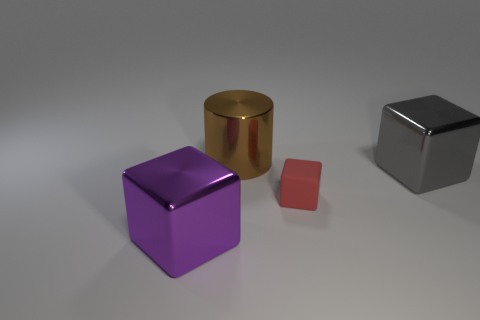Are there fewer large cubes that are in front of the big purple thing than large brown things left of the gray metallic block?
Offer a very short reply. Yes. There is a large shiny thing that is right of the small red matte object; is it the same shape as the large brown shiny object to the right of the purple block?
Offer a very short reply. No. What is the shape of the big object behind the large cube that is behind the purple object?
Make the answer very short. Cylinder. Are there any large brown things that have the same material as the big purple cube?
Give a very brief answer. Yes. What is the material of the cube to the left of the brown object?
Your answer should be very brief. Metal. What is the large purple block made of?
Offer a very short reply. Metal. Are the big object in front of the big gray metallic cube and the gray object made of the same material?
Your response must be concise. Yes. Is the number of big brown shiny cylinders left of the purple shiny block less than the number of big blue metallic blocks?
Keep it short and to the point. No. There is a cylinder that is the same size as the purple metal thing; what is its color?
Give a very brief answer. Brown. How many purple metallic objects have the same shape as the gray shiny object?
Give a very brief answer. 1. 